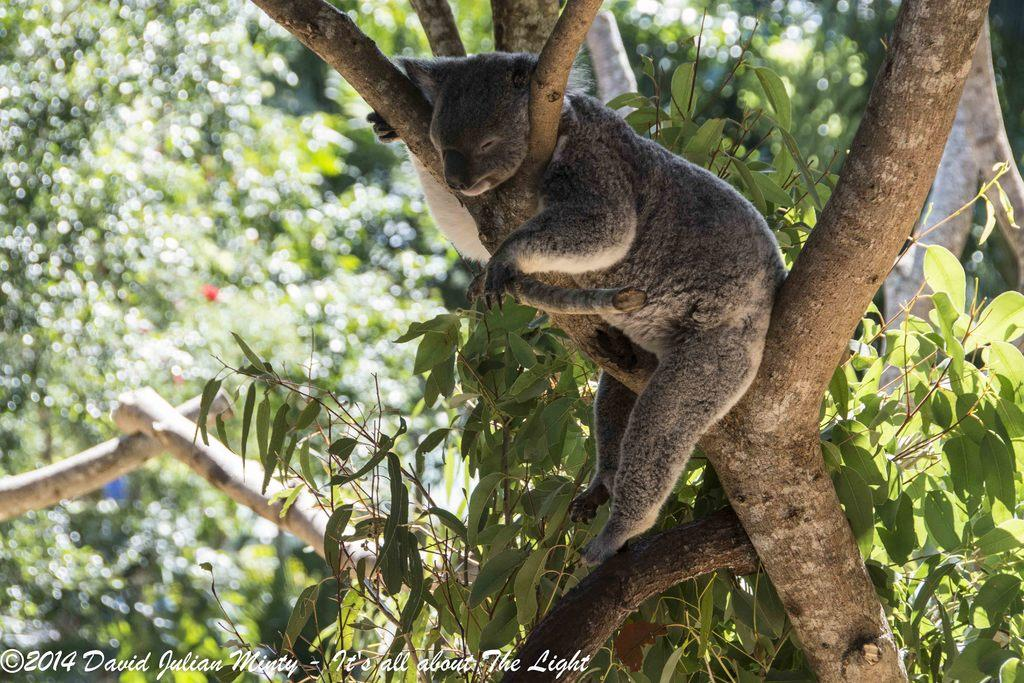What is the main subject of the image? There is an animal on a tree in the image. What can be seen in the background of the image? There are trees visible in the background of the image. Is there any text present in the image? Yes, there is text at the bottom of the image. What type of drawer can be seen in the image? There is no drawer present in the image. Can you describe the argument between the animals in the image? There are no animals arguing in the image; it only shows an animal on a tree. 